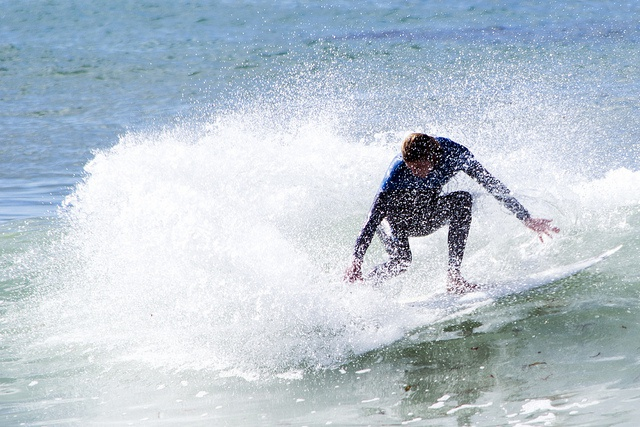Describe the objects in this image and their specific colors. I can see people in lightblue, black, lightgray, gray, and darkgray tones and surfboard in lightblue, lightgray, and darkgray tones in this image. 